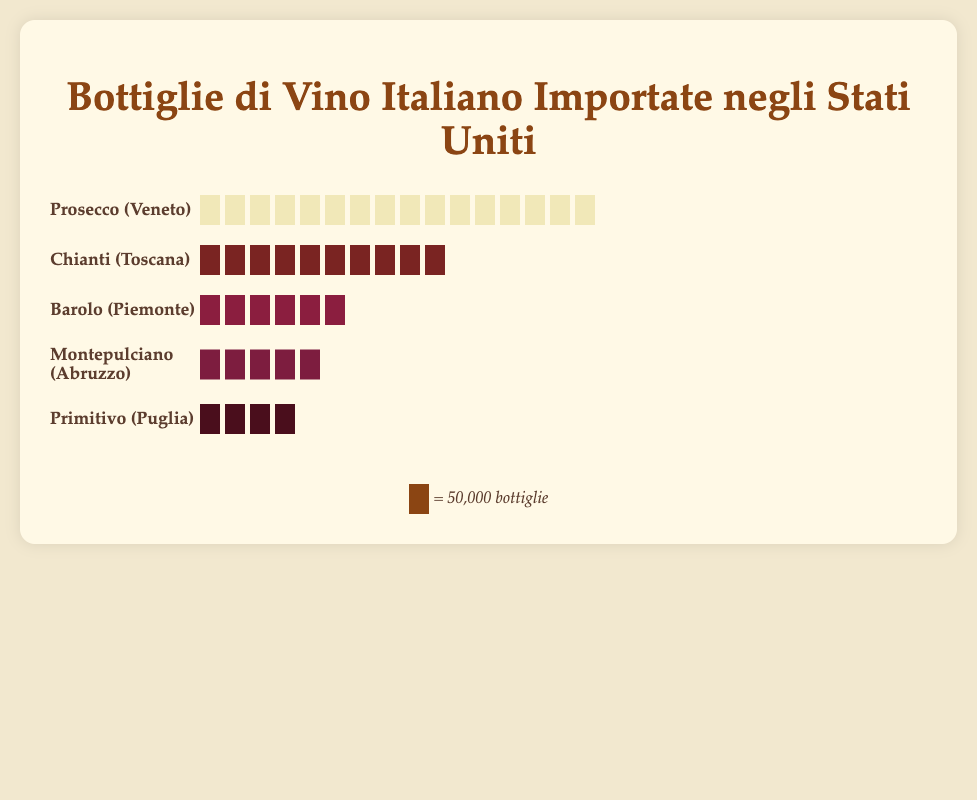What's the title of the plot? The title is always located at the top of the plot and usually provides a summary of what the plot is about. Here, the title is "Bottiglie di Vino Italiano Importate negli Stati Uniti".
Answer: Bottiglie di Vino Italiano Importate negli Stati Uniti Which variety of wine has the most bottles imported? To identify the variety with the most imports, count the number of icons for each variety and compare them. Prosecco from Veneto has the most icons, indicating the highest number of bottles imported.
Answer: Prosecco Which regions are represented in the plot? The regions are stated alongside each wine variety label. From the labels, the regions are Tuscany, Piedmont, Veneto, Abruzzo, and Puglia.
Answer: Tuscany, Piedmont, Veneto, Abruzzo, Puglia How many wine varieties are displayed in the plot? Count the number of different varieties listed in the plot. There are five wine varieties listed: Chianti, Barolo, Prosecco, Montepulciano, and Primitivo.
Answer: 5 Which wine variety from Tuscany is included in the plot? Refer to the region mentioned next to each wine variety. The variety listed as from Tuscany is Chianti.
Answer: Chianti Compare the number of bottles imported between Chianti and Barolo. Which has more and by how much? First, count the icons for Chianti and Barolo to find the number of bottles imported. Chianti has 10 icons (500,000 bottles) and Barolo has 6 icons (300,000 bottles). The difference is 500,000 - 300,000 = 200,000 bottles.
Answer: Chianti, 200,000 How many total bottles of wine are imported from Piedmont and Puglia combined? Sum up the number of bottles imported from each of these regions. For Piedmont (Barolo) it's 300,000 bottles, and for Puglia (Primitivo), it's 200,000 bottles. The combined total is 300,000 + 200,000 = 500,000 bottles.
Answer: 500,000 What is the average number of bottles imported for all wine varieties shown? Add the total number of bottles imported for all varieties together and divide by the number of varieties. Total bottles: 500,000 (Chianti) + 300,000 (Barolo) + 800,000 (Prosecco) + 250,000 (Montepulciano) + 200,000 (Primitivo) = 2,050,000. Divide by 5 varieties. 2,050,000 / 5 = 410,000 bottles on average.
Answer: 410,000 Which wine variety has the fewest bottles imported and from which region is it? Identify the variety with the least number of icons. Primitivo from Puglia has the fewest, with 4 icons (200,000 bottles).
Answer: Primitivo, Puglia 